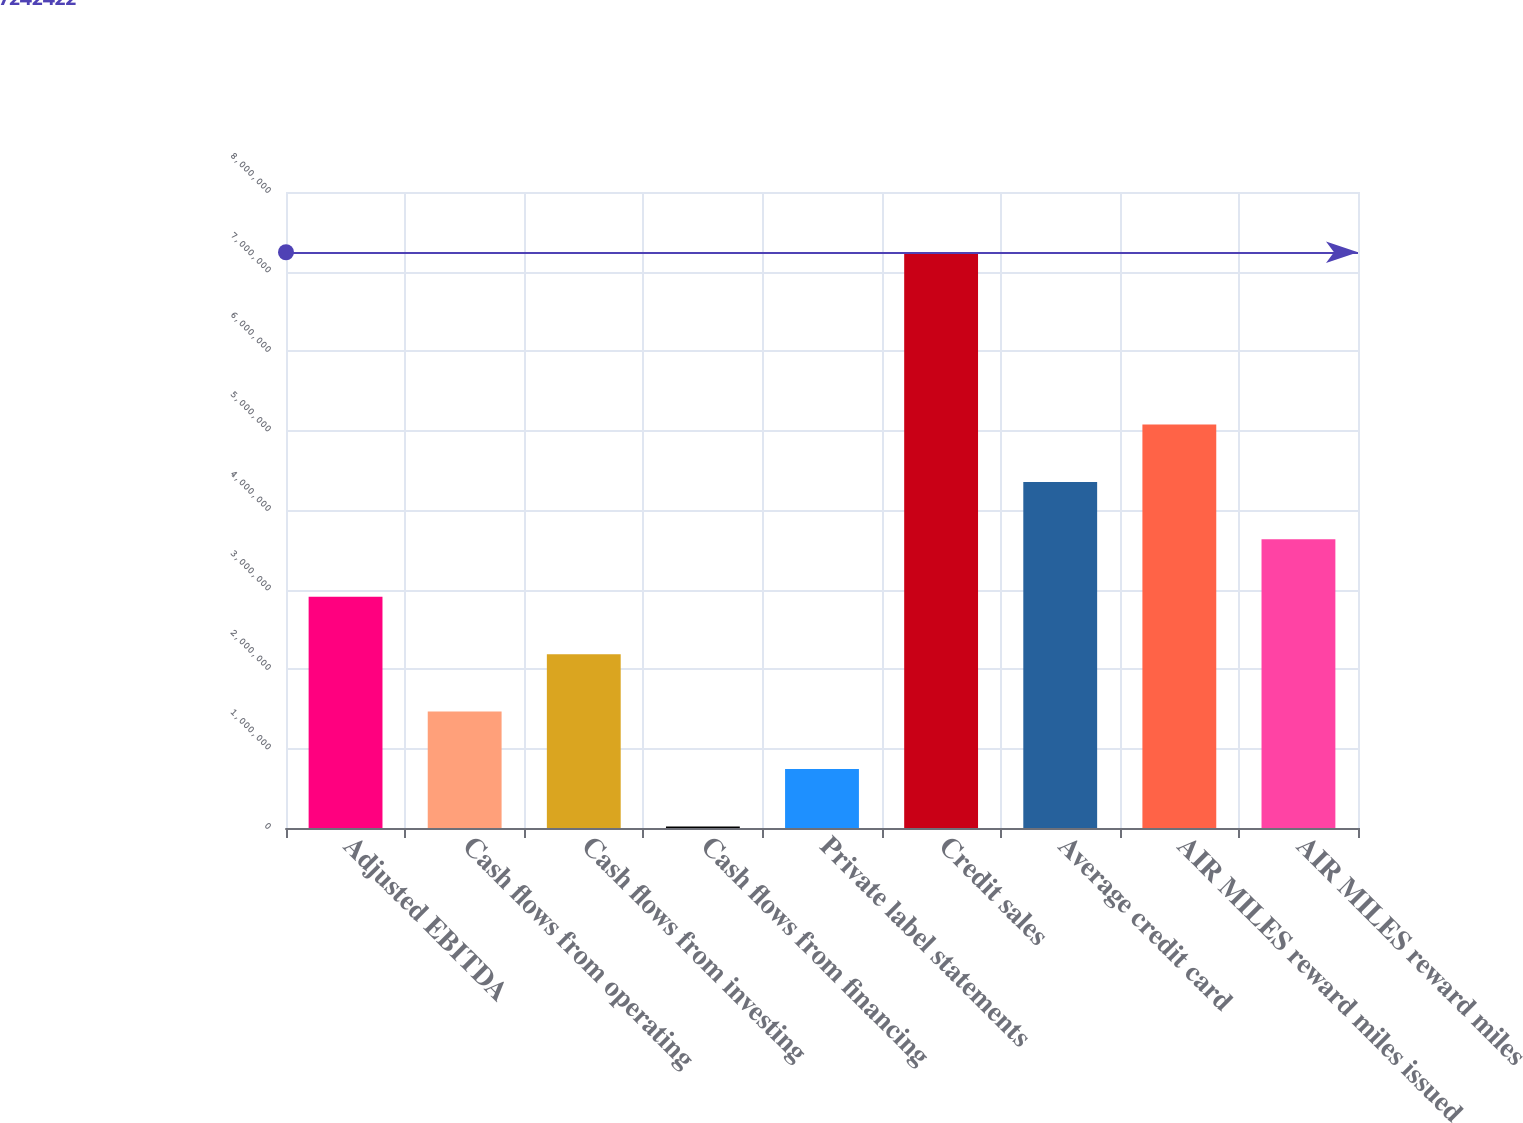Convert chart. <chart><loc_0><loc_0><loc_500><loc_500><bar_chart><fcel>Adjusted EBITDA<fcel>Cash flows from operating<fcel>Cash flows from investing<fcel>Cash flows from financing<fcel>Private label statements<fcel>Credit sales<fcel>Average credit card<fcel>AIR MILES reward miles issued<fcel>AIR MILES reward miles<nl><fcel>2.90915e+06<fcel>1.46473e+06<fcel>2.18694e+06<fcel>20306<fcel>742518<fcel>7.24242e+06<fcel>4.35358e+06<fcel>5.07579e+06<fcel>3.63136e+06<nl></chart> 